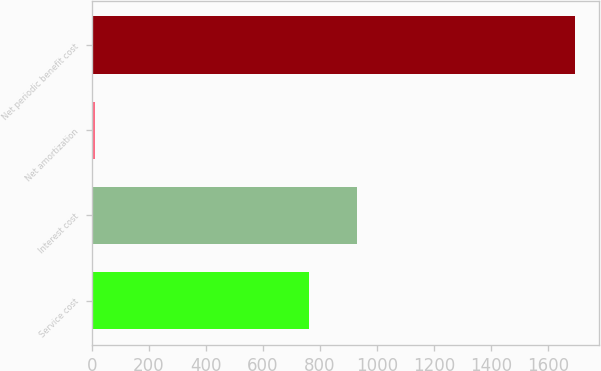Convert chart. <chart><loc_0><loc_0><loc_500><loc_500><bar_chart><fcel>Service cost<fcel>Interest cost<fcel>Net amortization<fcel>Net periodic benefit cost<nl><fcel>763<fcel>931.5<fcel>11<fcel>1696<nl></chart> 